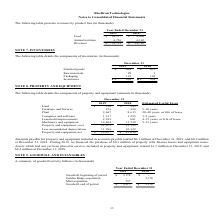From Ricebran Technologies's financial document, What are the respective values of land in 2018 and 2019? The document shows two values: $585 and $730 (in thousands). From the document: "Land 730 $ 585 $ Land 730 $ 585 $..." Also, What are the respective values of furniture and fixtures in 2018 and 2019? The document shows two values: 430 and 476 (in thousands). From the document: "Furniture and fixtures 476 430 5-10 years Furniture and fixtures 476 430 5-10 years..." Also, What are the respective values of plant in 2018 and 2019? The document shows two values: 8,613 and 9,667 (in thousands). From the document: "Plant 9,667 8,613 20-40 years, or life of lease Plant 9,667 8,613 20-40 years, or life of lease..." Also, can you calculate: What is the change in the land value between 2018 and 2019? Based on the calculation: 730 - 585 , the result is 145 (in thousands). This is based on the information: "Land 730 $ 585 $ Land 730 $ 585 $..." The key data points involved are: 585, 730. Also, can you calculate: What is the change in the furniture and fixtures value between 2018 and 2019? Based on the calculation: 476 - 430 , the result is 46 (in thousands). This is based on the information: "Furniture and fixtures 476 430 5-10 years Furniture and fixtures 476 430 5-10 years..." The key data points involved are: 430, 476. Also, can you calculate: What is the change in the plant value between 2018 and 2019? Based on the calculation: 9,667 - 8,613 , the result is 1054 (in thousands). This is based on the information: "Plant 9,667 8,613 20-40 years, or life of lease Plant 9,667 8,613 20-40 years, or life of lease..." The key data points involved are: 8,613, 9,667. 